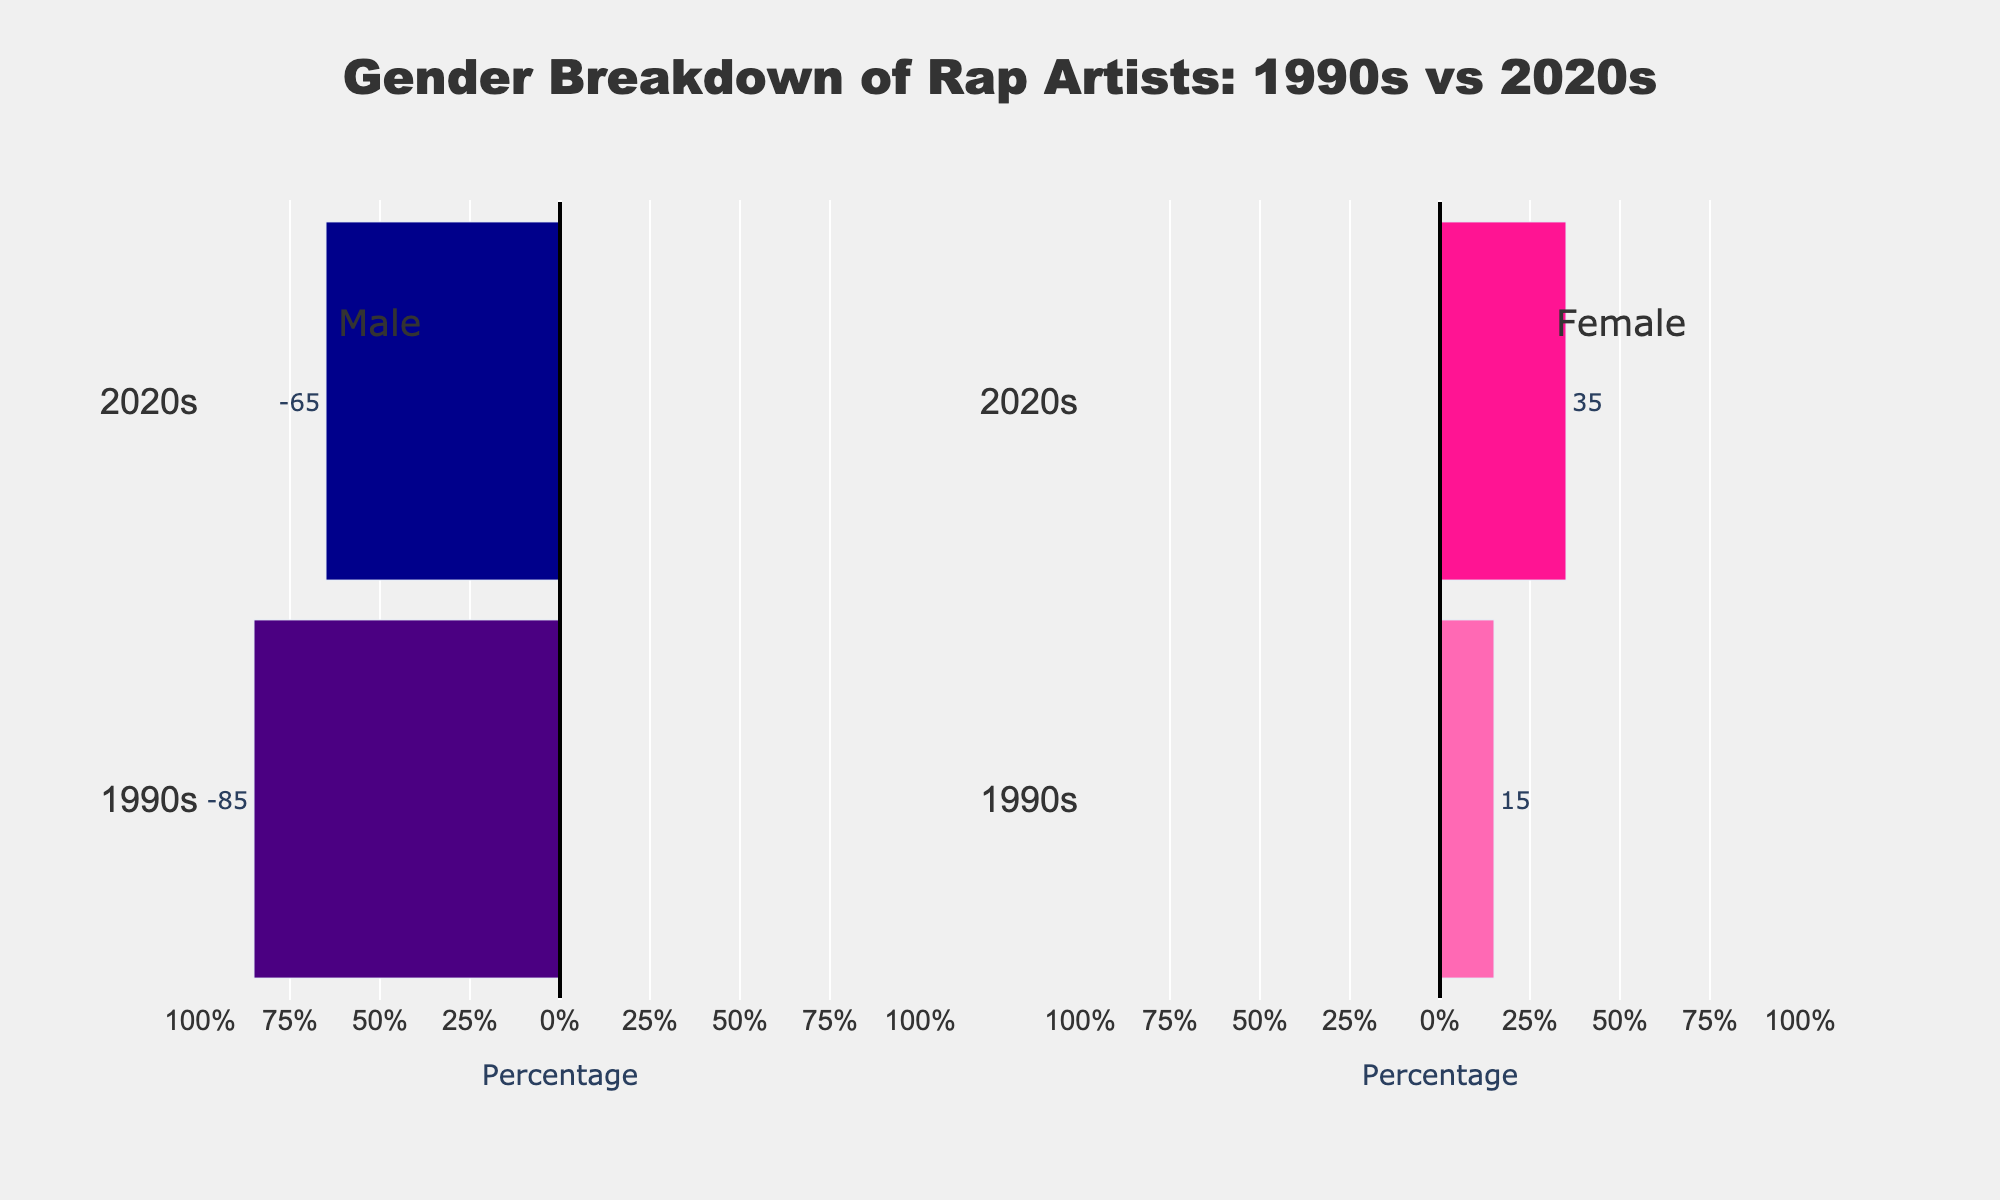What title does the figure have? The figure's title is located at the top and provides an overall description of the data being visualized. The title reads, "Gender Breakdown of Rap Artists: 1990s vs 2020s".
Answer: Gender Breakdown of Rap Artists: 1990s vs 2020s Which gender had more rap artists in the 1990s? By examining the bars for the 1990s, we see that the bar for males extends further than the bar for females. The data shows 85% male and 15% female.
Answer: Male How has the percentage of female rap artists changed from the 1990s to the 2020s? By comparing the bars for female rap artists in the 1990s and 2020s, we see an increase from 15% to 35%. The difference can be calculated as 35% - 15% = 20%.
Answer: Increased by 20% What percentage of rap artists were male in the 2020s? The bar for male rap artists in the 2020s shows a length representing 65%. This information can be directly read from the figure.
Answer: 65% How much has the percentage of male rap artists decreased from the 1990s to the 2020s? Observe the bars for male rap artists in both decades: 85% in the 1990s and 65% in the 2020s. The decrease can be calculated as 85% - 65% = 20%.
Answer: Decreased by 20% Which decade shows a more balanced gender distribution among rap artists? Compare the lengths of the bars for both genders in each decade. The 2020s have more balanced bars with 65% male and 35% female, unlike the 1990s which had 85% male and 15% female.
Answer: 2020s By how many percentage points did the female representation among rap artists increase from the 1990s to the 2020s? The figure shows 15% female artists in the 1990s and 35% in the 2020s. The increase in female representation is 35% - 15%, equating to 20 percentage points.
Answer: 20 percentage points What is the total percentage of male and female rap artists combined for each decade? Adding the percentages of males and females for each decade from the figure, we get 85% + 15% = 100% for the 1990s and 65% + 35% = 100% for the 2020s.
Answer: 100% for both decades 